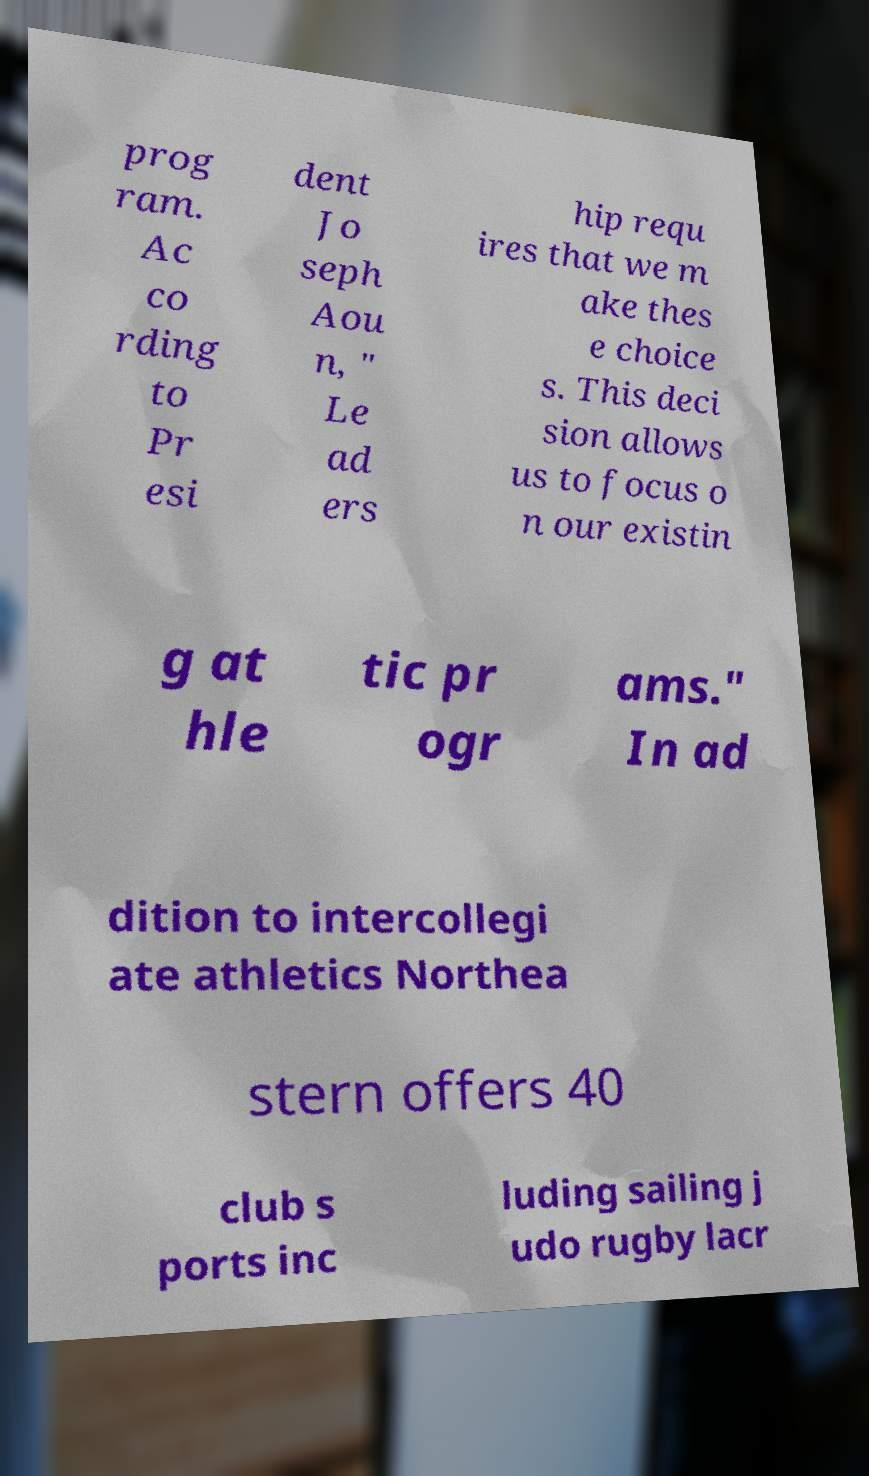Can you accurately transcribe the text from the provided image for me? prog ram. Ac co rding to Pr esi dent Jo seph Aou n, " Le ad ers hip requ ires that we m ake thes e choice s. This deci sion allows us to focus o n our existin g at hle tic pr ogr ams." In ad dition to intercollegi ate athletics Northea stern offers 40 club s ports inc luding sailing j udo rugby lacr 